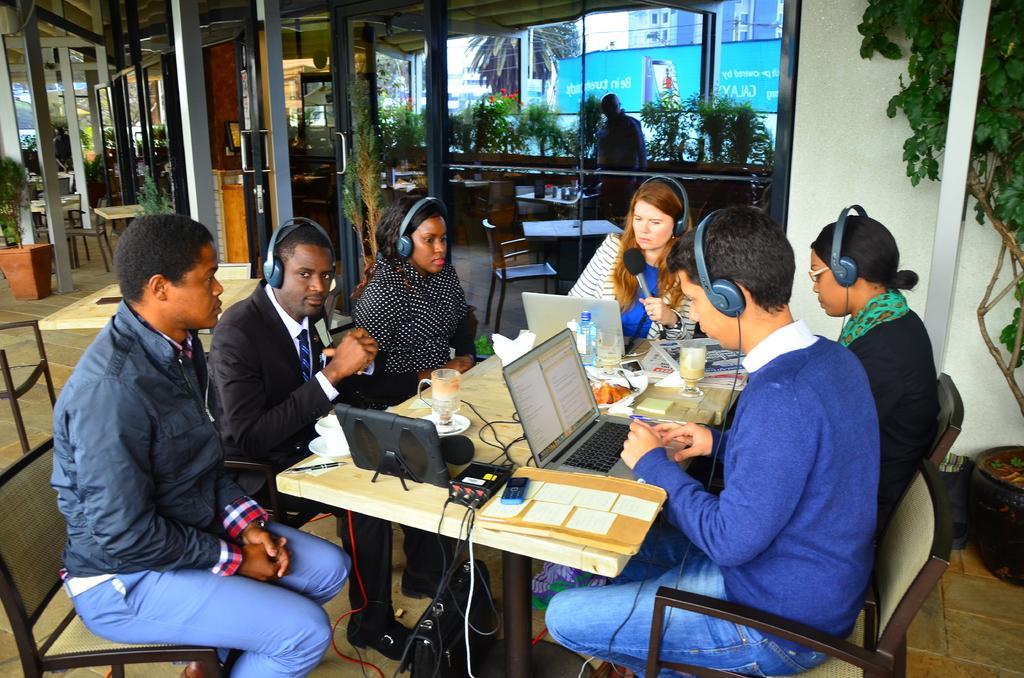How would you summarize this image in a sentence or two? In this image I can see there are group of people who are sitting on a chair in front of the table. On the table we have laptops, water bottle and few other objects on it. 